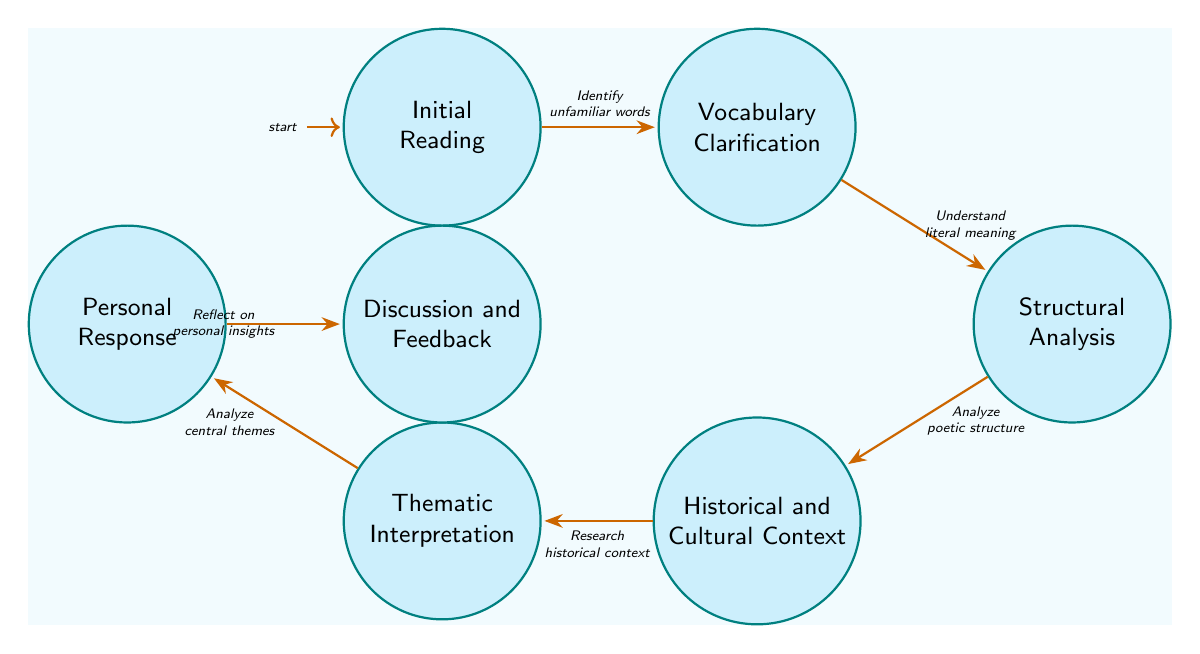What's the first state in the diagram? The first state is labeled "Initial Reading," and it is the starting point for analyzing the sonnet.
Answer: Initial Reading How many states are present in the diagram? By counting the number of labeled states, there are a total of seven distinct stages.
Answer: Seven What is the transition from "Vocabulary Clarification" to "Structural Analysis"? The edge between these two states indicates the transition is labeled "Understand literal meaning." This shows the progression as one analyzes the structure of the sonnet after clarifying vocabulary.
Answer: Understand literal meaning Which state follows "Contextual Analysis"? "Contextual Analysis" is also referred to as "Historical and Cultural Context." The next state that follows, according to the diagram, is "Thematic Interpretation."
Answer: Thematic Interpretation What connects "Personal Response" to "Discussion and Feedback"? The connection is represented by the edge labeled "Reflect on personal insights," which illustrates that after reflecting on personal interpretations, one engages in discussion for further feedback.
Answer: Reflect on personal insights Which state involves analyzing rhyme scheme and meter? The state that involves this analysis is "Structural Analysis," where the sonnet's form and meter are examined.
Answer: Structural Analysis What is the total number of transitions in the diagram? By counting the arrows connecting the states, there are a total of six transitions that illustrate the flow between different stages of understanding the sonnet.
Answer: Six What is the last state in the diagram? The last state in the sequence showcases "Discussion and Feedback," where insights are shared and clarified through discussion with others.
Answer: Discussion and Feedback What does the transition from "Interpretation" to "Personal Response" entail? This transition, labeled "Analyze central themes," signifies the process of deriving personal insights based on the thematic analysis of the sonnet.
Answer: Analyze central themes 